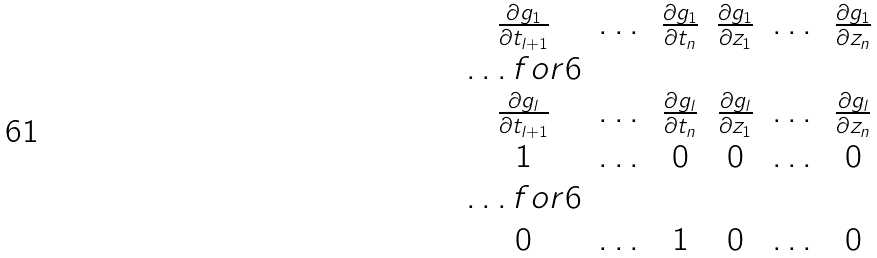Convert formula to latex. <formula><loc_0><loc_0><loc_500><loc_500>\begin{matrix} \frac { \partial g _ { 1 } } { \partial t _ { l + 1 } } & \dots & \frac { \partial g _ { 1 } } { \partial t _ { n } } & \frac { \partial g _ { 1 } } { \partial z _ { 1 } } & \dots & \frac { \partial g _ { 1 } } { \partial z _ { n } } \\ \hdots f o r { 6 } \\ \frac { \partial g _ { l } } { \partial t _ { l + 1 } } & \dots & \frac { \partial g _ { l } } { \partial t _ { n } } & \frac { \partial g _ { l } } { \partial z _ { 1 } } & \dots & \frac { \partial g _ { l } } { \partial z _ { n } } \\ 1 & \dots & 0 & 0 & \dots & 0 \\ \hdots f o r { 6 } \\ 0 & \dots & 1 & 0 & \dots & 0 \end{matrix}</formula> 